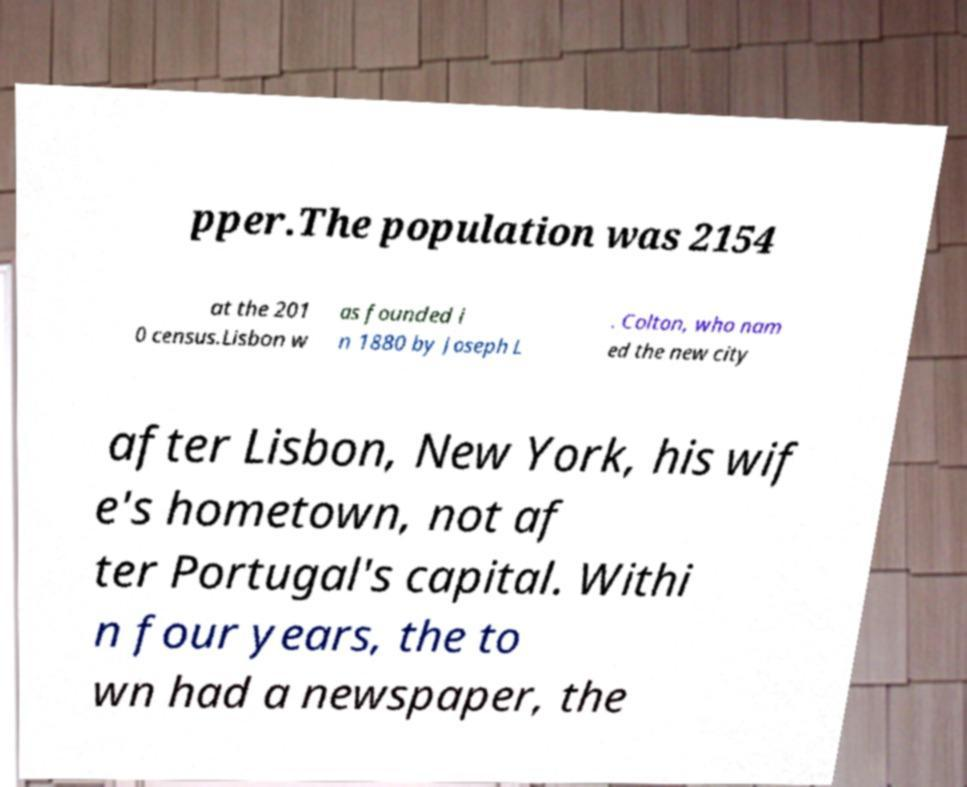There's text embedded in this image that I need extracted. Can you transcribe it verbatim? pper.The population was 2154 at the 201 0 census.Lisbon w as founded i n 1880 by Joseph L . Colton, who nam ed the new city after Lisbon, New York, his wif e's hometown, not af ter Portugal's capital. Withi n four years, the to wn had a newspaper, the 